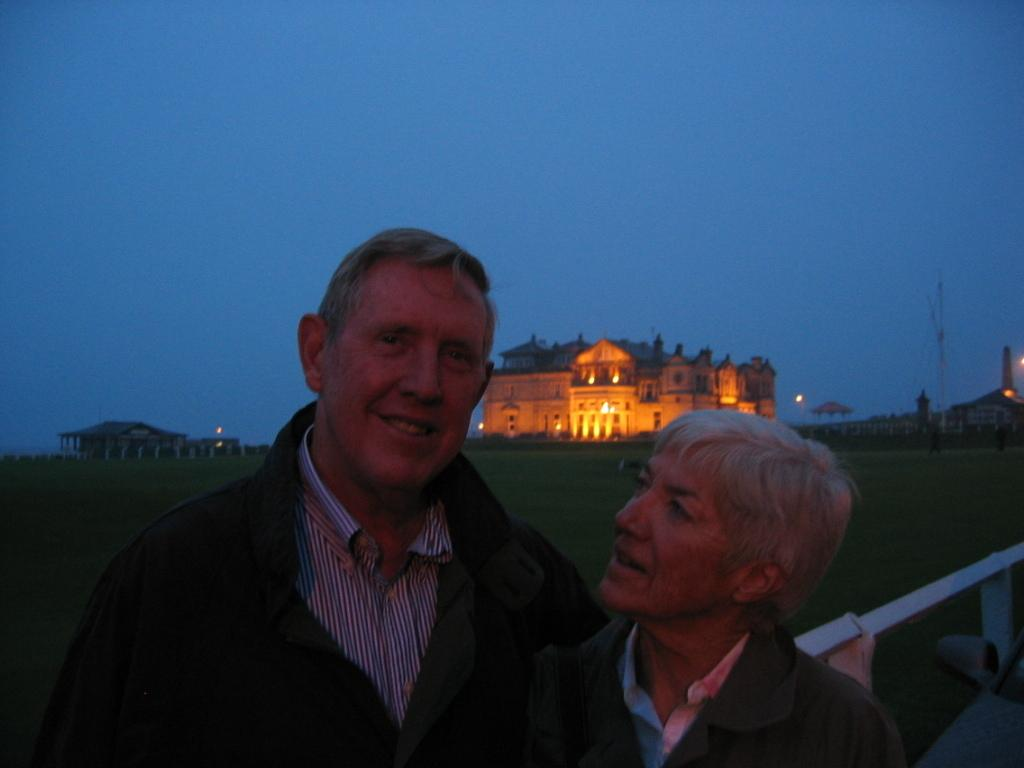How many people are in the image? There are two people in the image. What is the facial expression of the people in the image? The people are smiling. What can be seen in the background of the image? There are buildings, grass, and the sky visible in the background of the image. What type of truck is parked near the people in the image? There is no truck present in the image. What is the occupation of the farmer in the image? There is no farmer present in the image. 